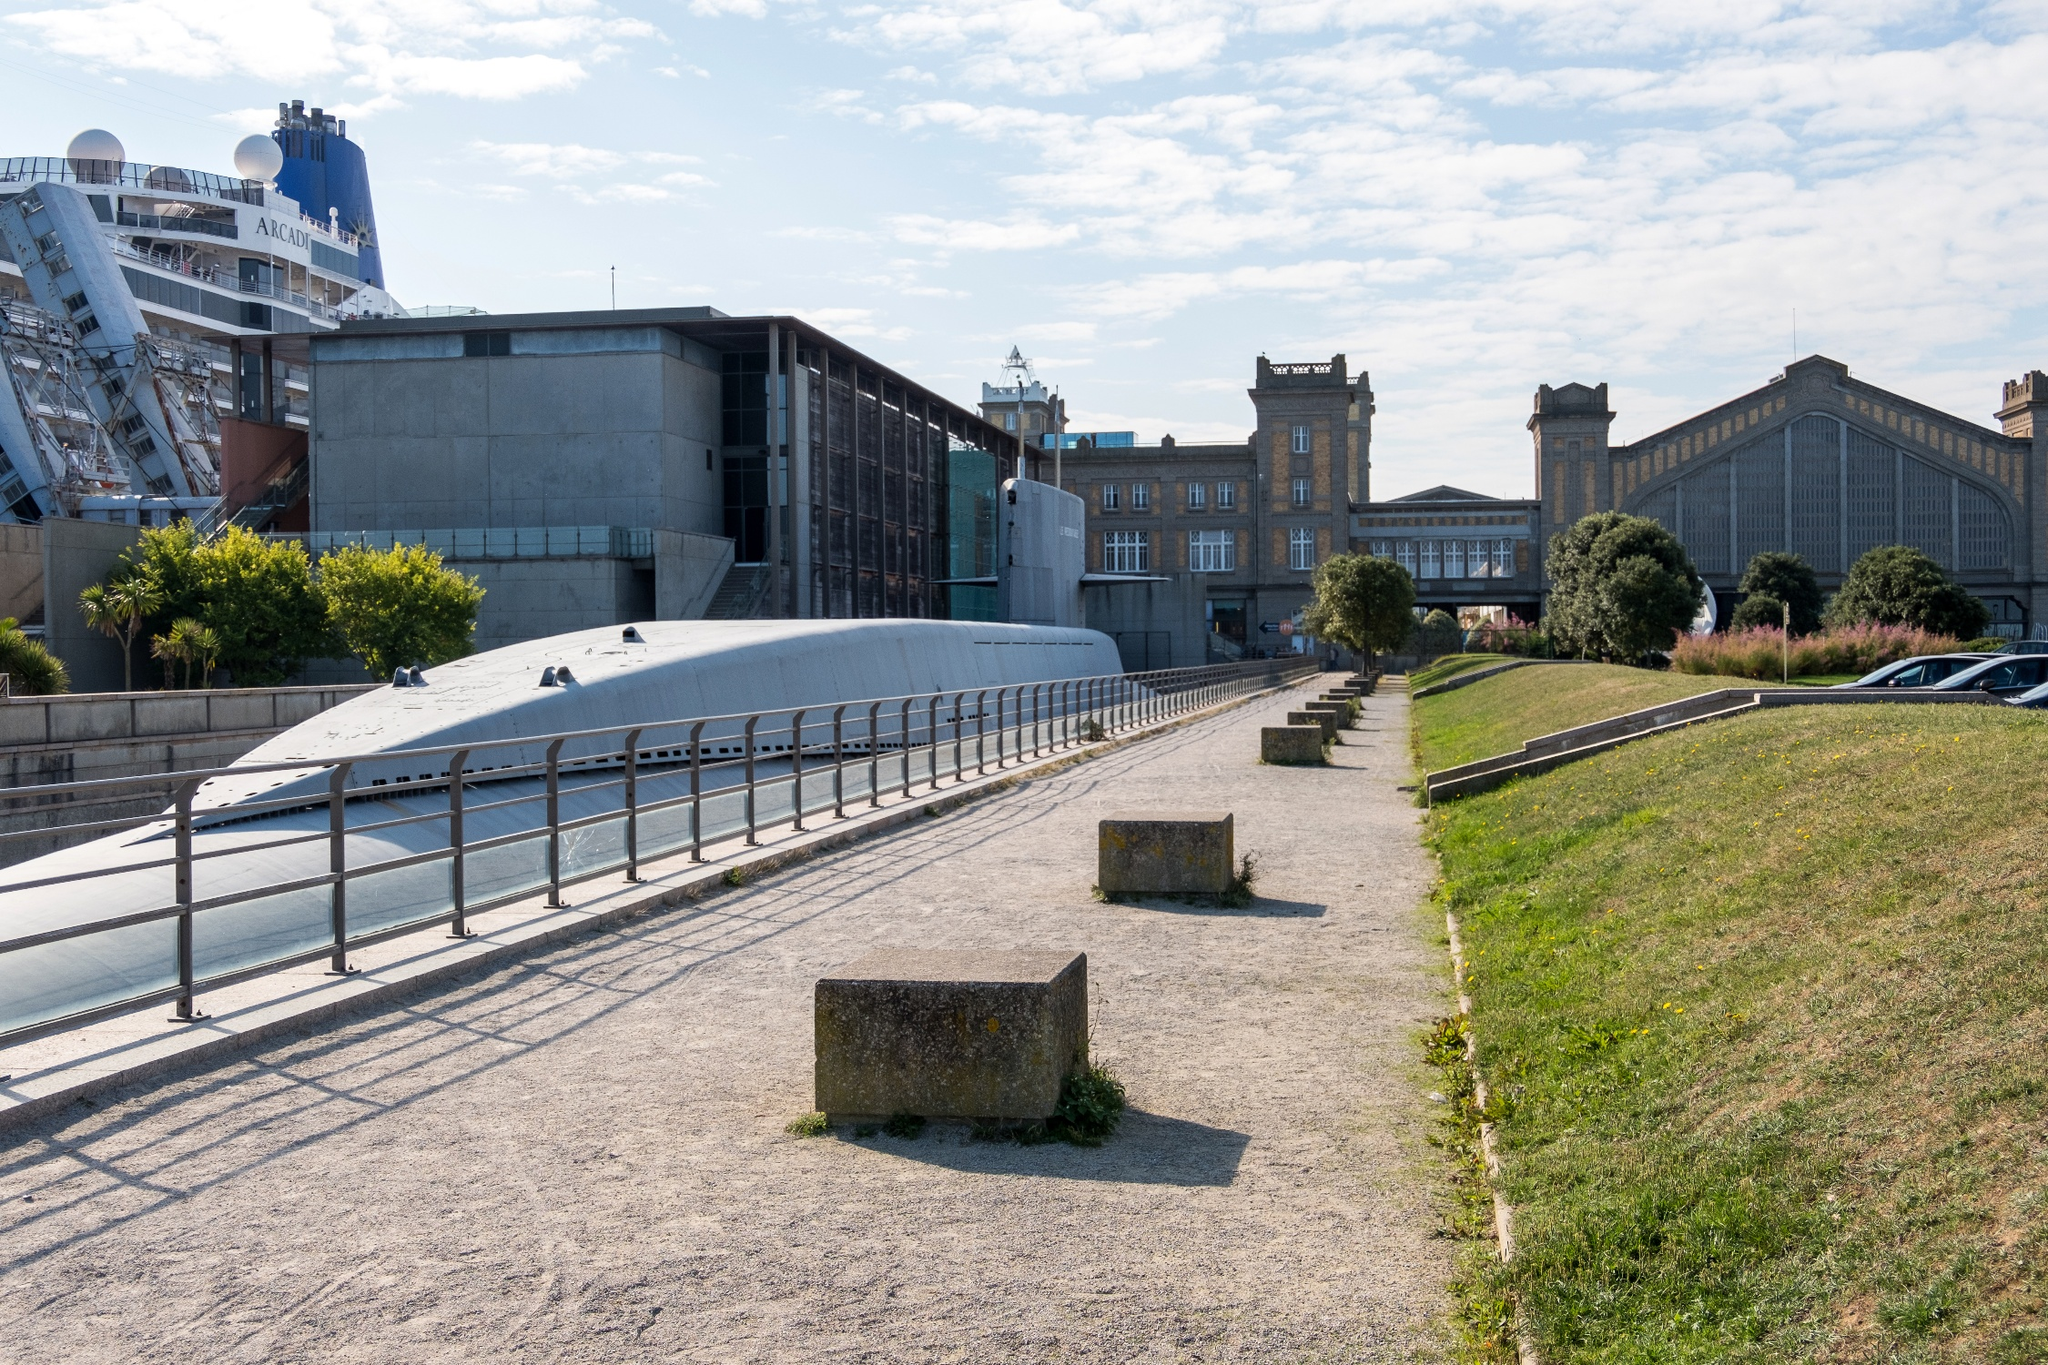What might a day in the life of a resident in this area look like? A resident of Cherbourg-Octeville might start their day with a peaceful walk along the pedestrian path, enjoying the fresh morning air and perhaps a coffee from a nearby café. They might then head off to work in one of the many historic buildings, perhaps in the maritime industry. Lunchtime could be spent at a quaint bistro overlooking the docks, where they can observe cruise ships and other vessels. In the evening, they might take a leisurely stroll back home, passing by modern apartments that blend effortlessly with the historic architecture. The day ends with a beautiful sunset over the serene port, a reminder of the timeless balance between tradition and modernity that defines their city. 